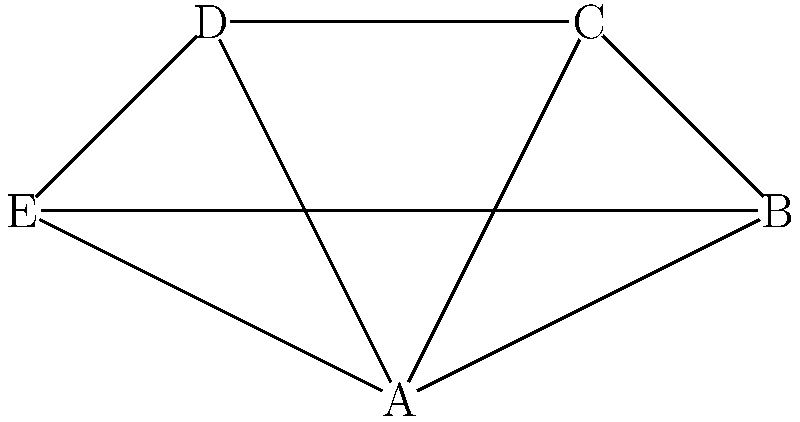Consider the network diagram representing five women's rights organizations (A, B, C, D, E) in the Bahamas. If each connection represents a collaborative project, and the group structure follows the rule that any two organizations connected by exactly two paths can initiate a joint advocacy campaign, how many pairs of organizations can launch such a campaign? Express your answer using set notation. To solve this problem, we need to follow these steps:

1. Identify all pairs of organizations connected by exactly two paths:

   a) A and C: A-B-C and A-C
   b) A and D: A-C-D and A-D
   c) A and E: A-B-E and A-E
   d) B and D: B-A-D and B-C-D
   e) C and E: C-A-E and C-D-E

2. Count the number of pairs that satisfy the condition:
   There are 5 pairs that can initiate a joint advocacy campaign.

3. Express the answer using set notation:
   We can represent this as the cardinality of the set of all pairs that satisfy the condition.

   Let S be the set of all pairs that can initiate a joint advocacy campaign.
   S = {(A,C), (A,D), (A,E), (B,D), (C,E)}

   The cardinality of this set is expressed as |S|.

Therefore, the answer can be expressed as |S| = 5.
Answer: |S| = 5 